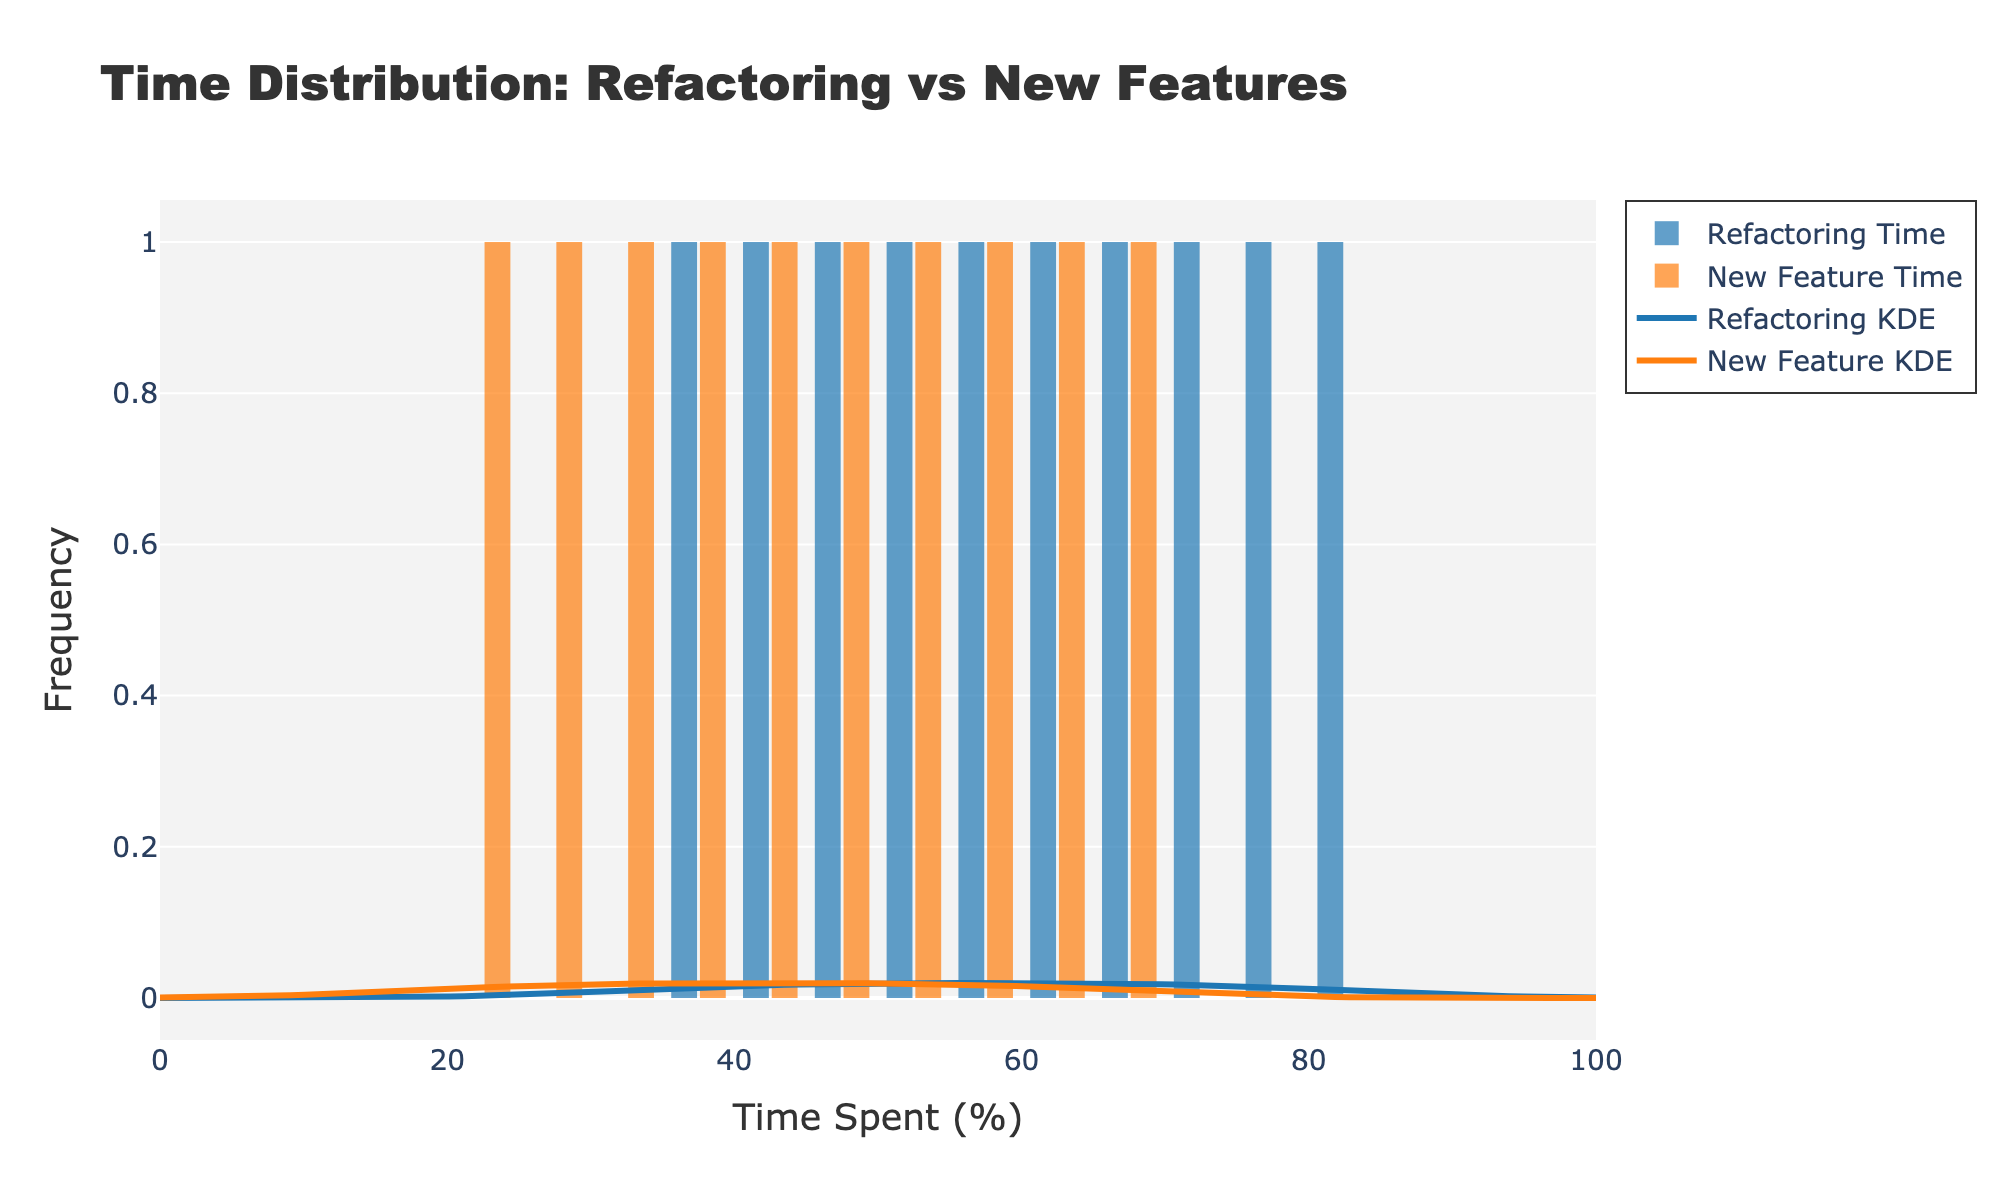What's the title of the figure? The title is visible at the top of the figure.
Answer: Time Distribution: Refactoring vs New Features What are the x-axis and y-axis labels of the figure? The x-axis label is 'Time Spent (%)', and the y-axis label is 'Frequency'. These labels can be found along the axes of the plot.
Answer: x-axis: Time Spent (%), y-axis: Frequency What do the blue bars and orange bars represent? The blue bars represent 'Refactoring Time' and the orange bars represent 'New Feature Time'. This can be determined by looking at the legend on the figure.
Answer: Blue: Refactoring Time, Orange: New Feature Time Which time category has the higher peak in the KDE curve? The KDE peak for Refactoring Time (blue curve) is observed to be higher than the peak for New Feature Time (orange curve). This can be visually identified by comparing the heights of the two KDE curves.
Answer: Refactoring Time What is the sum of all KDE peaks? To find the sum, we observe the individual peak heights of each KDE curve. The blue curve (Refactoring) has a peak approximately at y=0.04, and the orange curve (New Feature) at y=0.03. Summing these gives 0.04 + 0.03.
Answer: 0.07 Between Refactoring Time and New Feature Time, which has a wider distribution as shown in the histogram? The histogram bars for Refactoring Time (blue) are spread more widely compared to the New Feature Time (orange), indicating a wider distribution.
Answer: Refactoring Time At which time percentage does the New Feature Time histogram have the highest frequency? By observing the histogram, New Feature Time reaches its highest frequency within the 60-65% time range.
Answer: 60-65% How does the distribution of time spent on new features compare to refactoring in terms of symmetry? The distribution of Refactoring Time appears to be more symmetrical around its peak, while New Feature Time has a skewed distribution with a peak towards the higher time percentages (60-65%).
Answer: Refactoring Time: Symmetrical, New Feature Time: Skewed What is the range of refactoring times used in the histogram bins? The histogram bins for Refactoring Time span from 30 to 85%. This can be identified by looking at the start and end points of the bins.
Answer: 30%-85% Which time category had the lowest recorded time spent, and what was it? The lowest recorded time spent is 20%, which falls under the Refactoring Time category as indicated by the figure.
Answer: Refactoring Time, 20% 